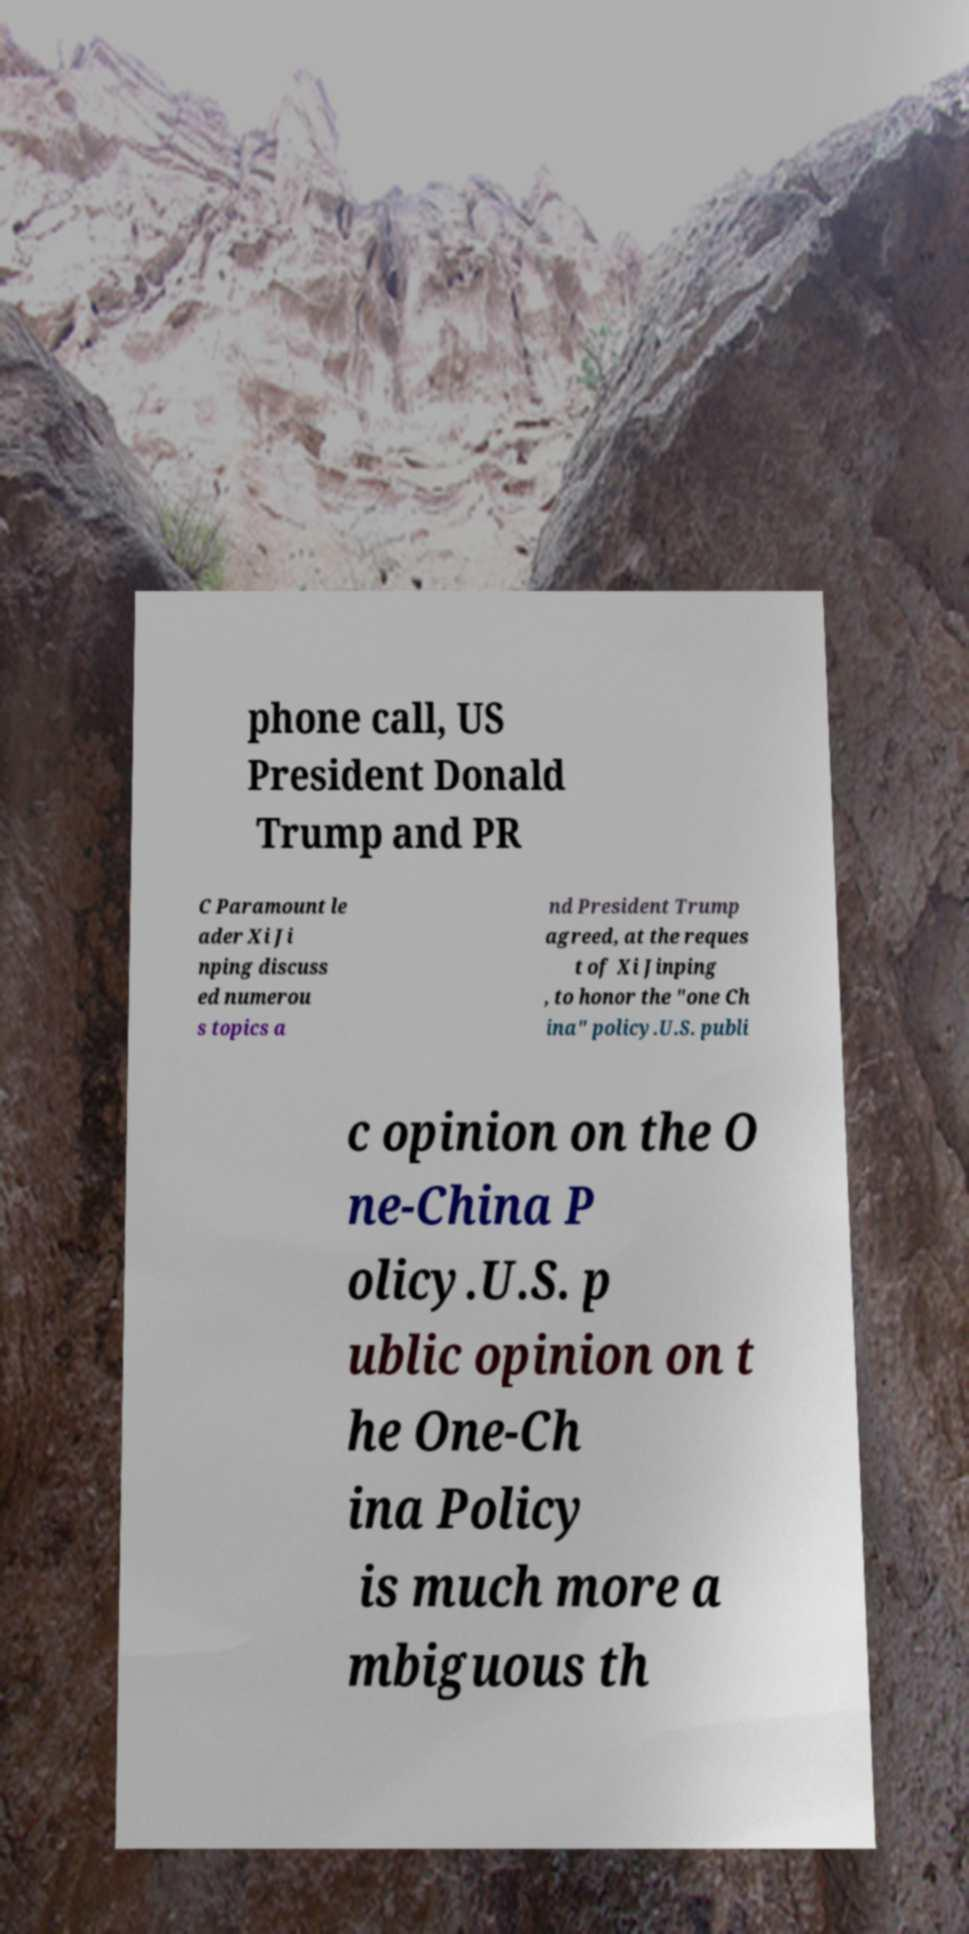Please read and relay the text visible in this image. What does it say? phone call, US President Donald Trump and PR C Paramount le ader Xi Ji nping discuss ed numerou s topics a nd President Trump agreed, at the reques t of Xi Jinping , to honor the "one Ch ina" policy.U.S. publi c opinion on the O ne-China P olicy.U.S. p ublic opinion on t he One-Ch ina Policy is much more a mbiguous th 